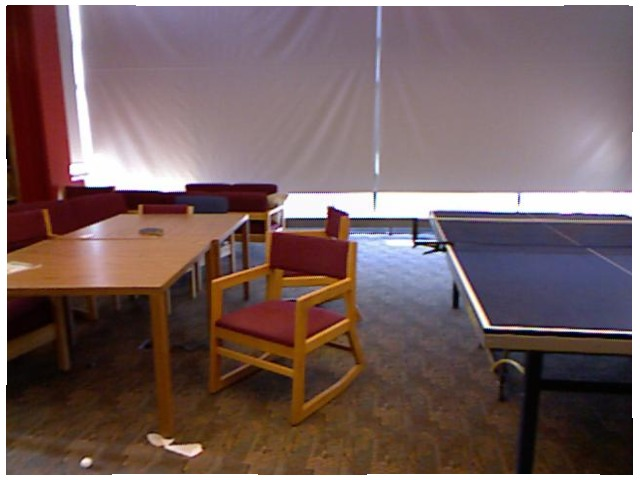<image>
Can you confirm if the table is under the chair? No. The table is not positioned under the chair. The vertical relationship between these objects is different. Is there a chair on the table? No. The chair is not positioned on the table. They may be near each other, but the chair is not supported by or resting on top of the table. Is there a table behind the chair? Yes. From this viewpoint, the table is positioned behind the chair, with the chair partially or fully occluding the table. Is the chair behind the game table? No. The chair is not behind the game table. From this viewpoint, the chair appears to be positioned elsewhere in the scene. Is there a net above the table? Yes. The net is positioned above the table in the vertical space, higher up in the scene. 